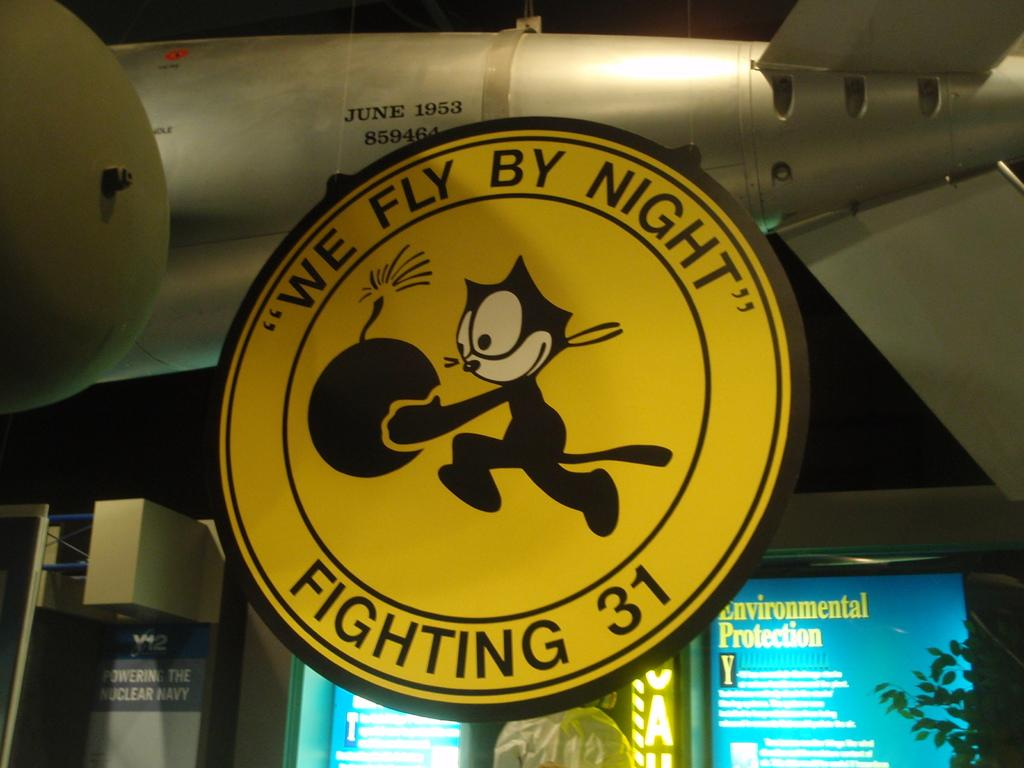<image>
Present a compact description of the photo's key features. A sign with a cartoon cat holding a bomb that says "We Fly By Night" and "Fighting 31". 